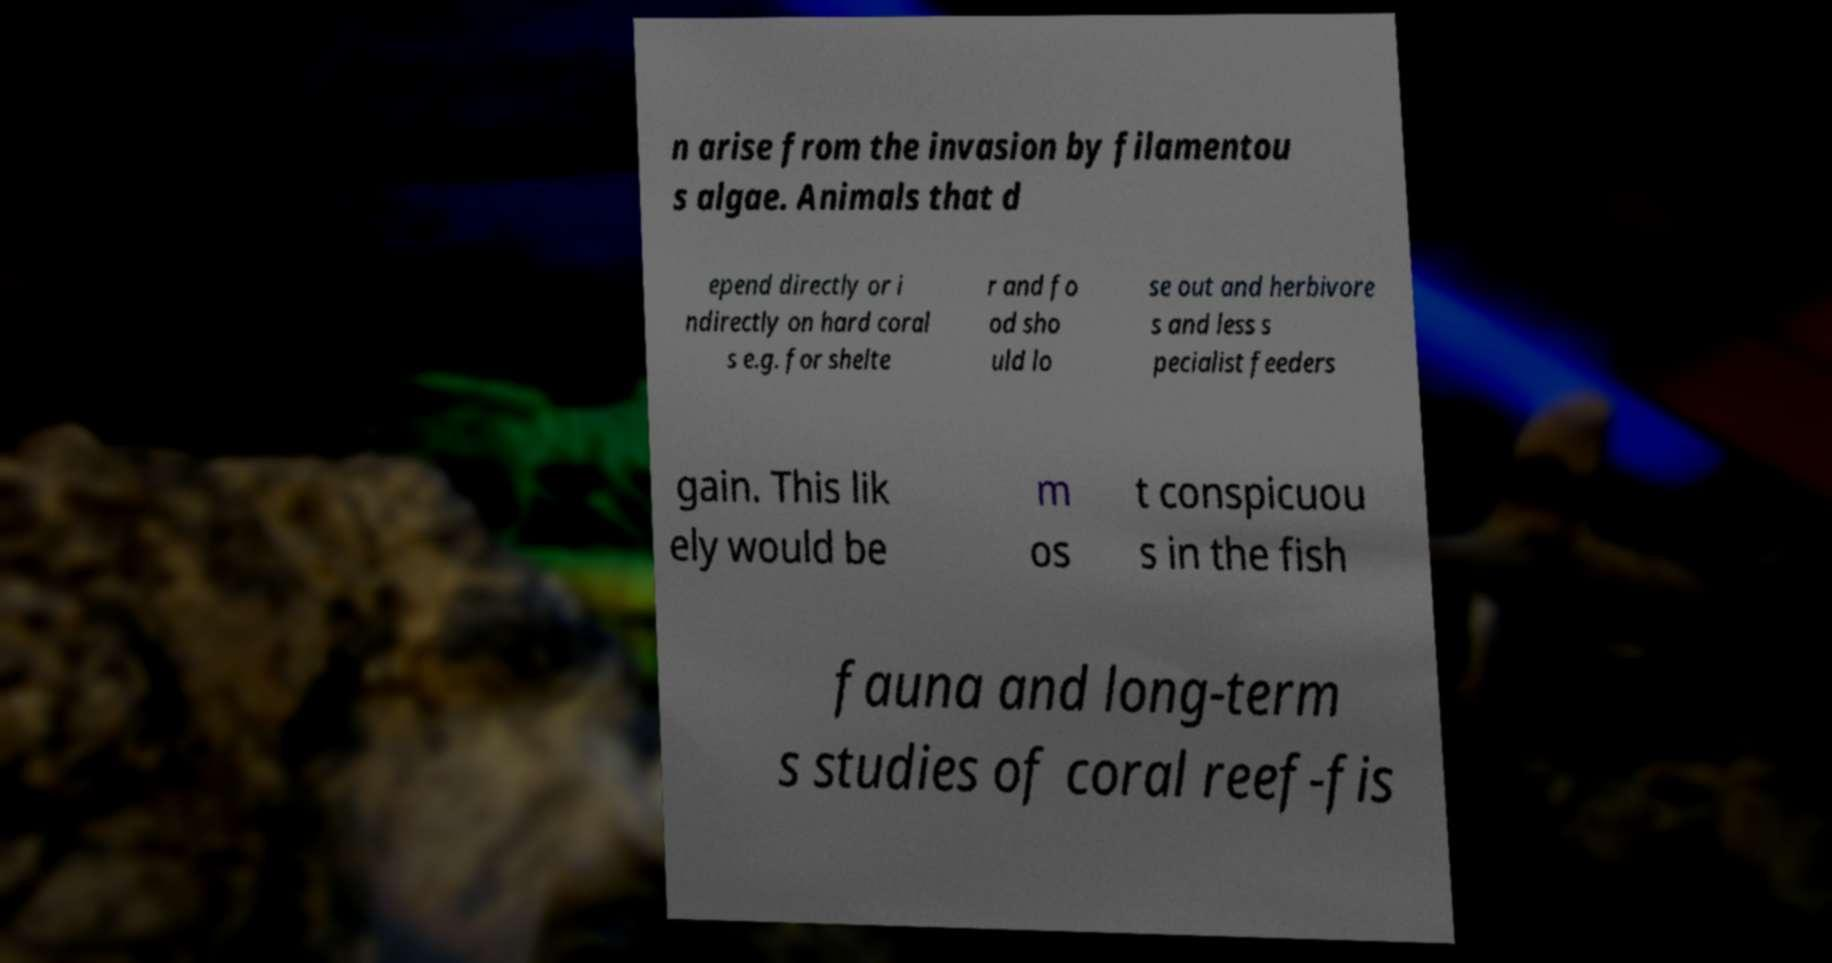Please read and relay the text visible in this image. What does it say? n arise from the invasion by filamentou s algae. Animals that d epend directly or i ndirectly on hard coral s e.g. for shelte r and fo od sho uld lo se out and herbivore s and less s pecialist feeders gain. This lik ely would be m os t conspicuou s in the fish fauna and long-term s studies of coral reef-fis 